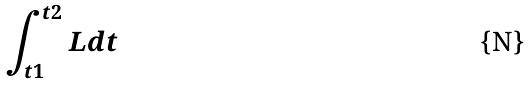Convert formula to latex. <formula><loc_0><loc_0><loc_500><loc_500>\int _ { t 1 } ^ { t 2 } L d t</formula> 